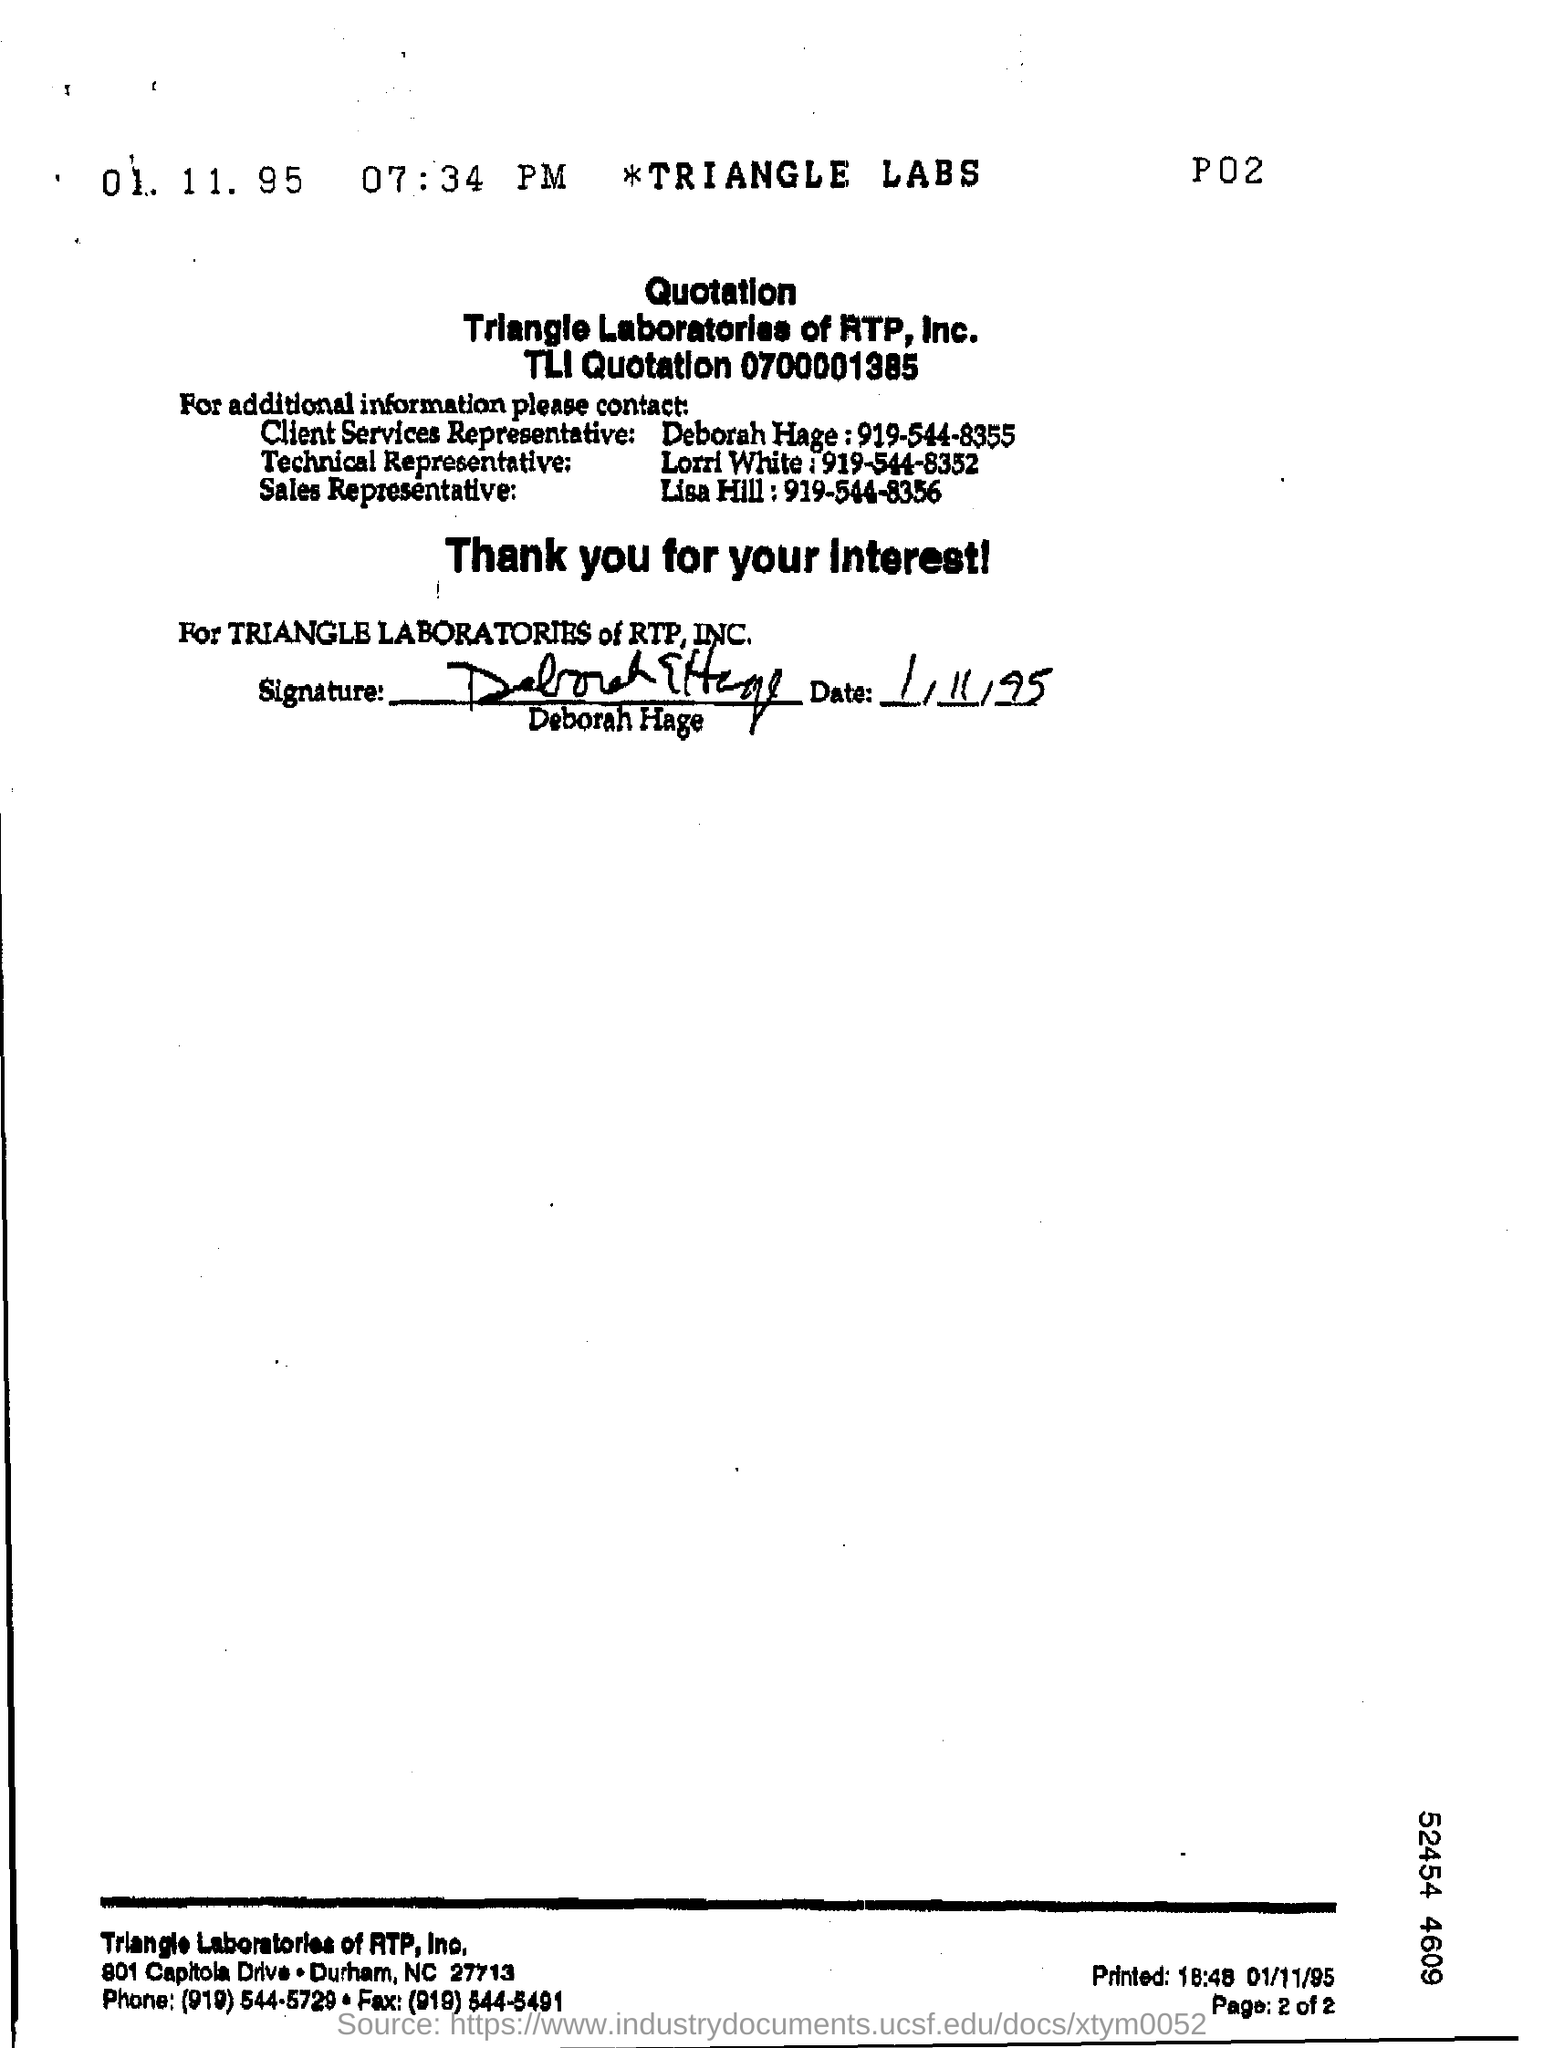Give some essential details in this illustration. The contact number of Deborah Hage is 919-544-8355. 